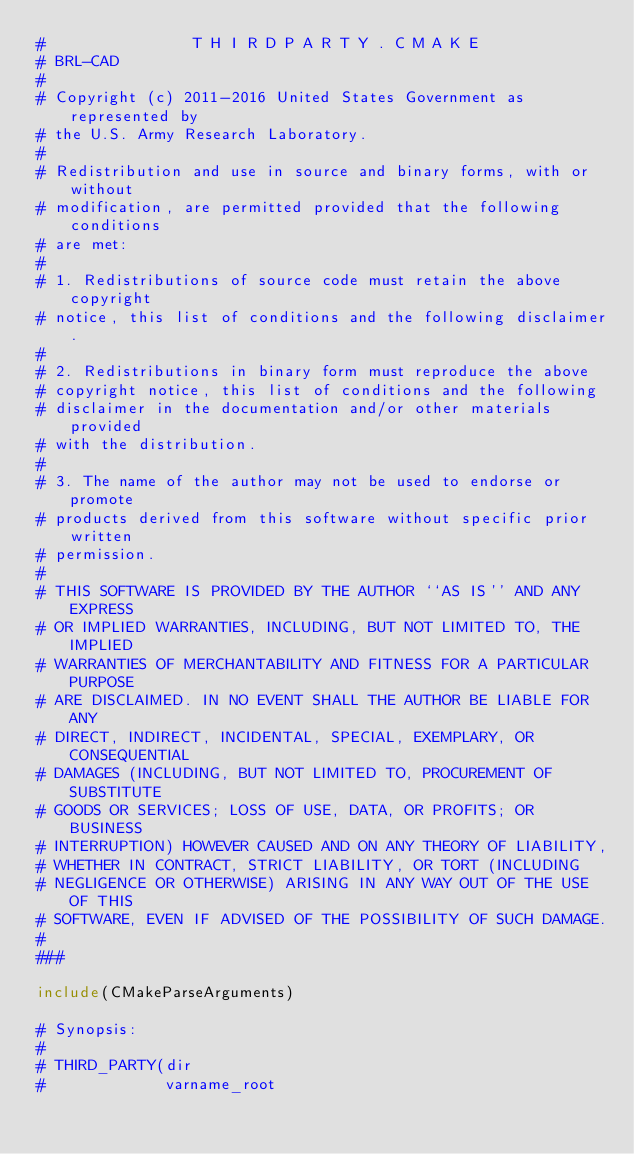<code> <loc_0><loc_0><loc_500><loc_500><_CMake_>#                T H I R D P A R T Y . C M A K E
# BRL-CAD
#
# Copyright (c) 2011-2016 United States Government as represented by
# the U.S. Army Research Laboratory.
#
# Redistribution and use in source and binary forms, with or without
# modification, are permitted provided that the following conditions
# are met:
#
# 1. Redistributions of source code must retain the above copyright
# notice, this list of conditions and the following disclaimer.
#
# 2. Redistributions in binary form must reproduce the above
# copyright notice, this list of conditions and the following
# disclaimer in the documentation and/or other materials provided
# with the distribution.
#
# 3. The name of the author may not be used to endorse or promote
# products derived from this software without specific prior written
# permission.
#
# THIS SOFTWARE IS PROVIDED BY THE AUTHOR ``AS IS'' AND ANY EXPRESS
# OR IMPLIED WARRANTIES, INCLUDING, BUT NOT LIMITED TO, THE IMPLIED
# WARRANTIES OF MERCHANTABILITY AND FITNESS FOR A PARTICULAR PURPOSE
# ARE DISCLAIMED. IN NO EVENT SHALL THE AUTHOR BE LIABLE FOR ANY
# DIRECT, INDIRECT, INCIDENTAL, SPECIAL, EXEMPLARY, OR CONSEQUENTIAL
# DAMAGES (INCLUDING, BUT NOT LIMITED TO, PROCUREMENT OF SUBSTITUTE
# GOODS OR SERVICES; LOSS OF USE, DATA, OR PROFITS; OR BUSINESS
# INTERRUPTION) HOWEVER CAUSED AND ON ANY THEORY OF LIABILITY,
# WHETHER IN CONTRACT, STRICT LIABILITY, OR TORT (INCLUDING
# NEGLIGENCE OR OTHERWISE) ARISING IN ANY WAY OUT OF THE USE OF THIS
# SOFTWARE, EVEN IF ADVISED OF THE POSSIBILITY OF SUCH DAMAGE.
#
###

include(CMakeParseArguments)

# Synopsis:
#
# THIRD_PARTY(dir
#             varname_root</code> 